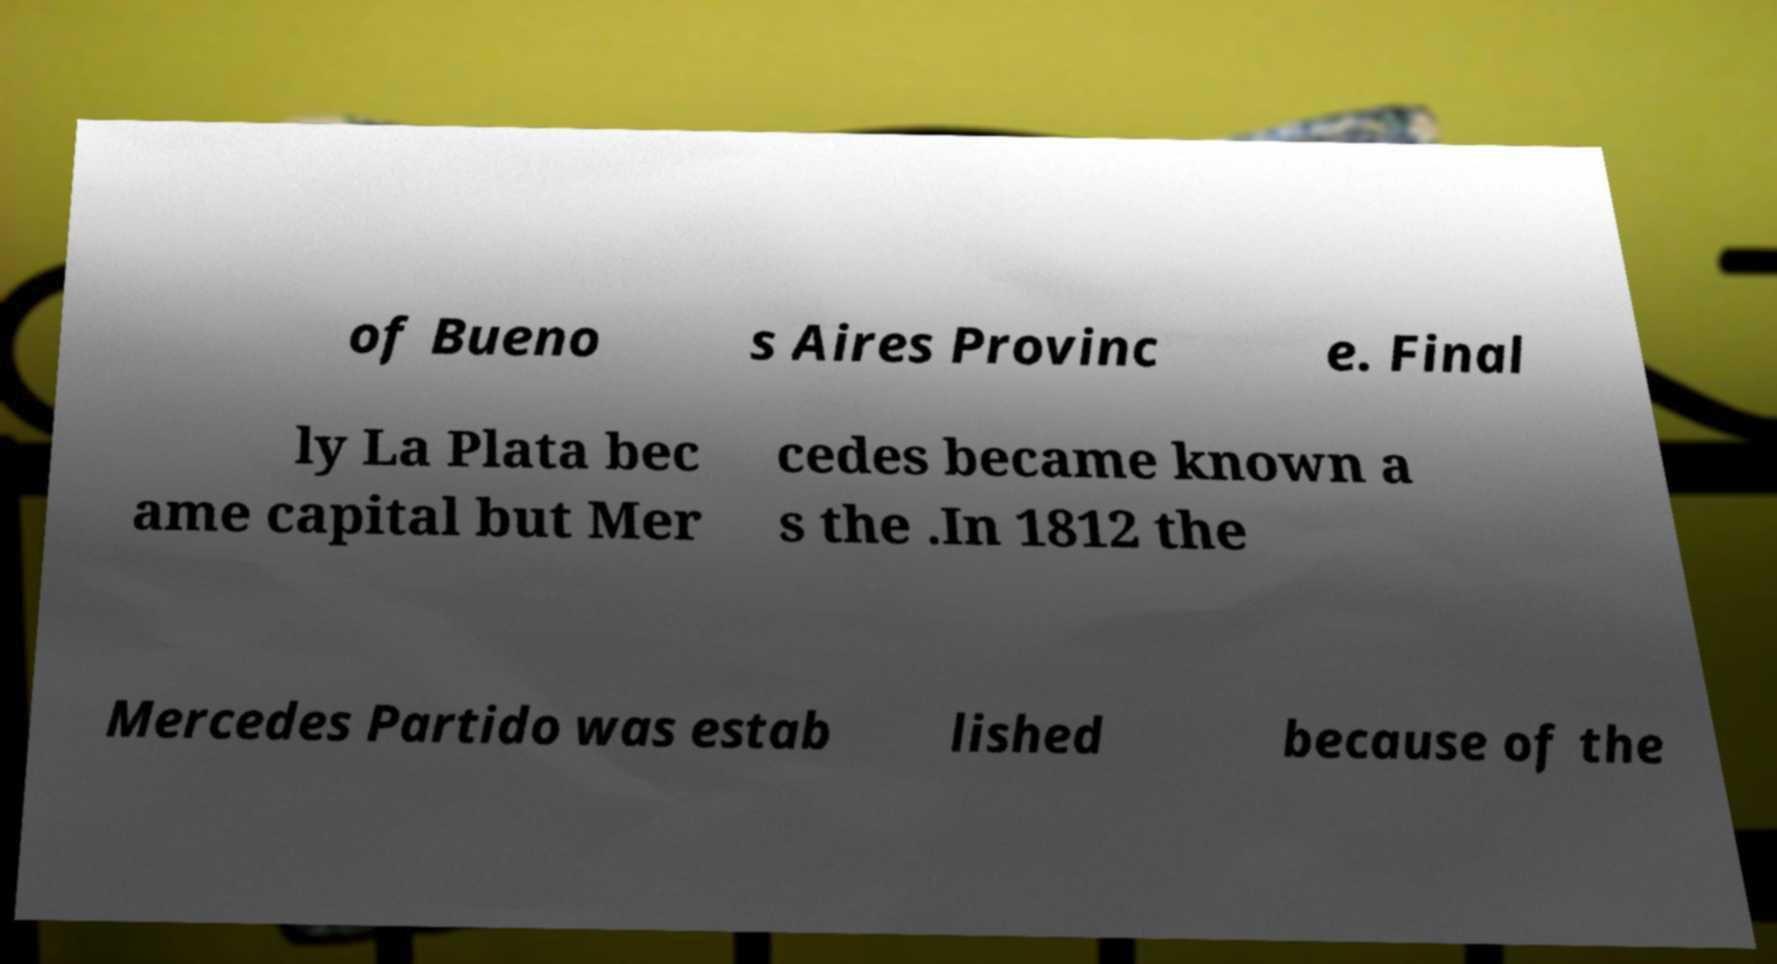What messages or text are displayed in this image? I need them in a readable, typed format. of Bueno s Aires Provinc e. Final ly La Plata bec ame capital but Mer cedes became known a s the .In 1812 the Mercedes Partido was estab lished because of the 